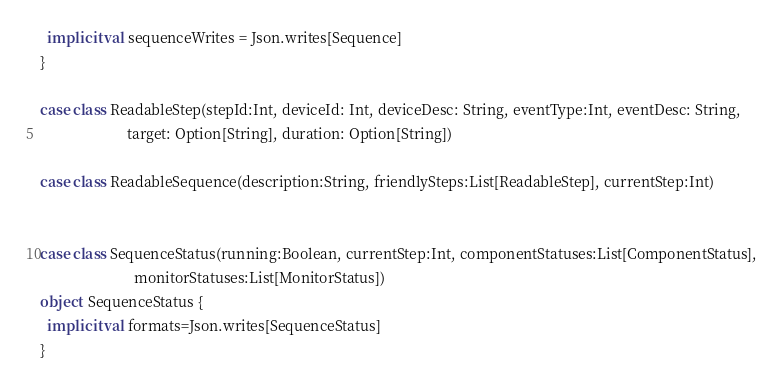Convert code to text. <code><loc_0><loc_0><loc_500><loc_500><_Scala_>
  implicit val sequenceWrites = Json.writes[Sequence]
}

case class ReadableStep(stepId:Int, deviceId: Int, deviceDesc: String, eventType:Int, eventDesc: String,
                        target: Option[String], duration: Option[String])

case class ReadableSequence(description:String, friendlySteps:List[ReadableStep], currentStep:Int)


case class SequenceStatus(running:Boolean, currentStep:Int, componentStatuses:List[ComponentStatus],
                          monitorStatuses:List[MonitorStatus])
object  SequenceStatus {
  implicit val formats=Json.writes[SequenceStatus]
}
</code> 